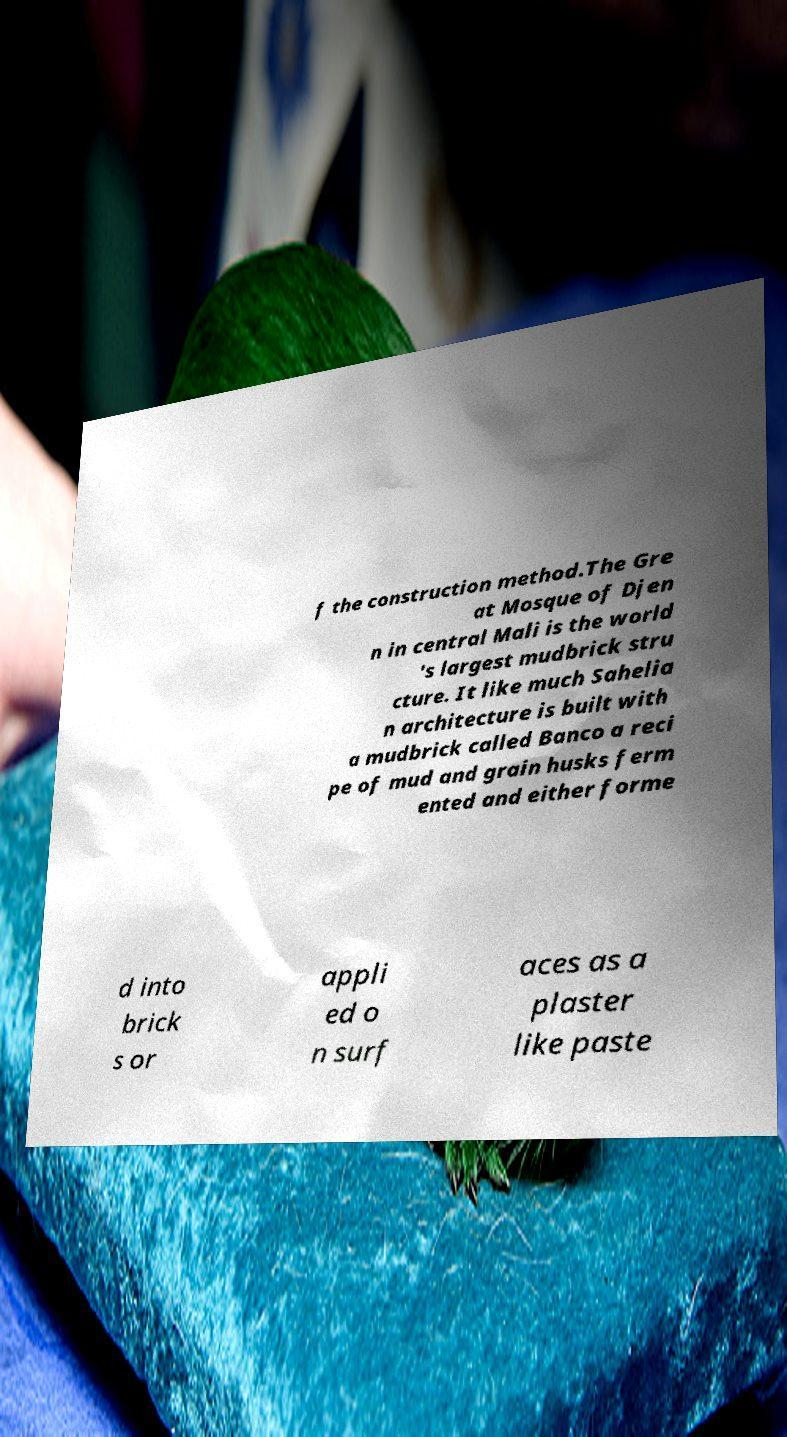Please identify and transcribe the text found in this image. f the construction method.The Gre at Mosque of Djen n in central Mali is the world 's largest mudbrick stru cture. It like much Sahelia n architecture is built with a mudbrick called Banco a reci pe of mud and grain husks ferm ented and either forme d into brick s or appli ed o n surf aces as a plaster like paste 